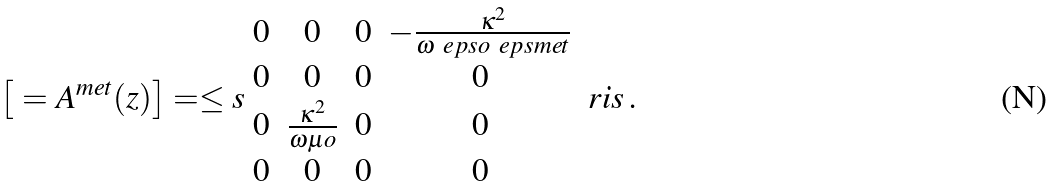<formula> <loc_0><loc_0><loc_500><loc_500>\left [ \ = A ^ { m e t } ( z ) \right ] = \leq s \begin{array} { c c c c } 0 & 0 & 0 & - \frac { \kappa ^ { 2 } } { \omega \ e p s o \ e p s m e t } \\ 0 & 0 & 0 & 0 \\ 0 & \frac { \kappa ^ { 2 } } { \omega \mu o } & 0 & 0 \\ 0 & 0 & 0 & 0 \end{array} \ r i s \, .</formula> 